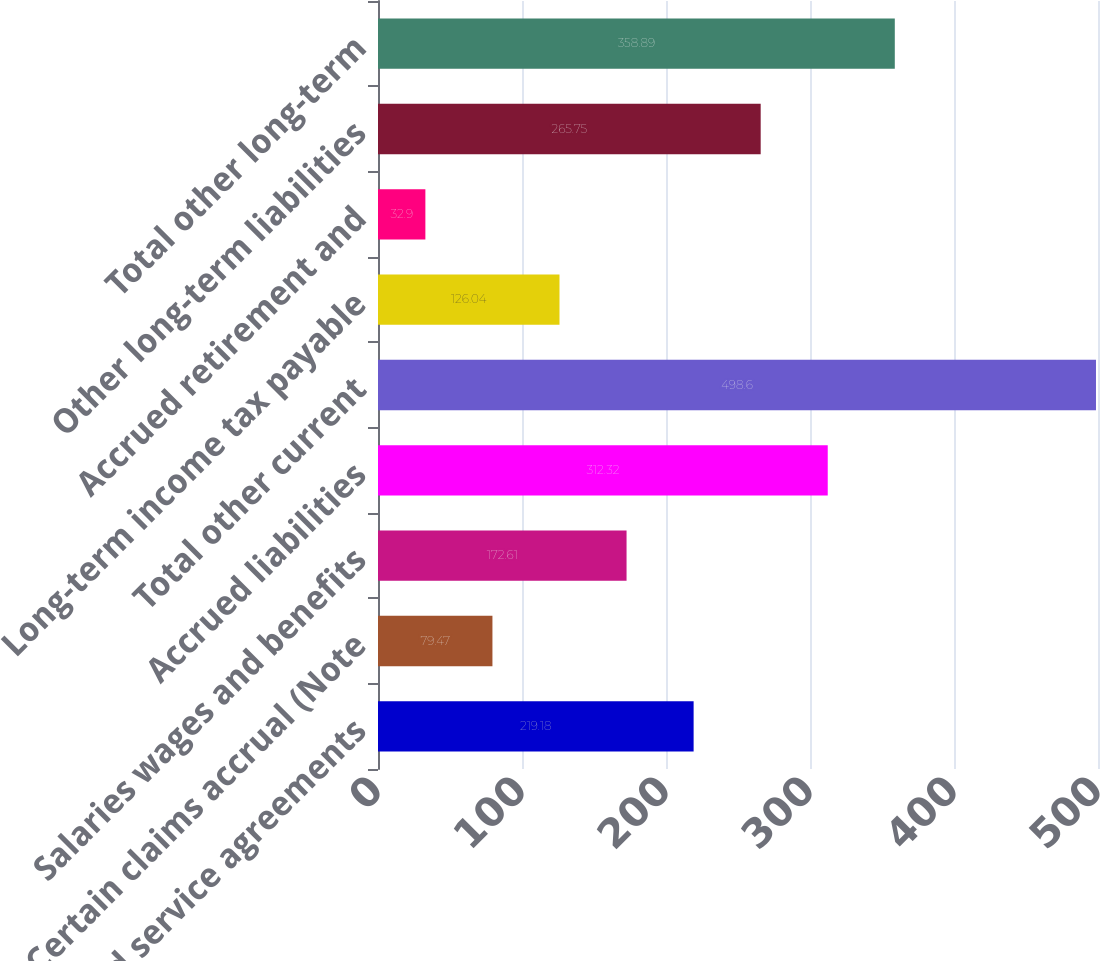Convert chart. <chart><loc_0><loc_0><loc_500><loc_500><bar_chart><fcel>License and service agreements<fcel>Certain claims accrual (Note<fcel>Salaries wages and benefits<fcel>Accrued liabilities<fcel>Total other current<fcel>Long-term income tax payable<fcel>Accrued retirement and<fcel>Other long-term liabilities<fcel>Total other long-term<nl><fcel>219.18<fcel>79.47<fcel>172.61<fcel>312.32<fcel>498.6<fcel>126.04<fcel>32.9<fcel>265.75<fcel>358.89<nl></chart> 